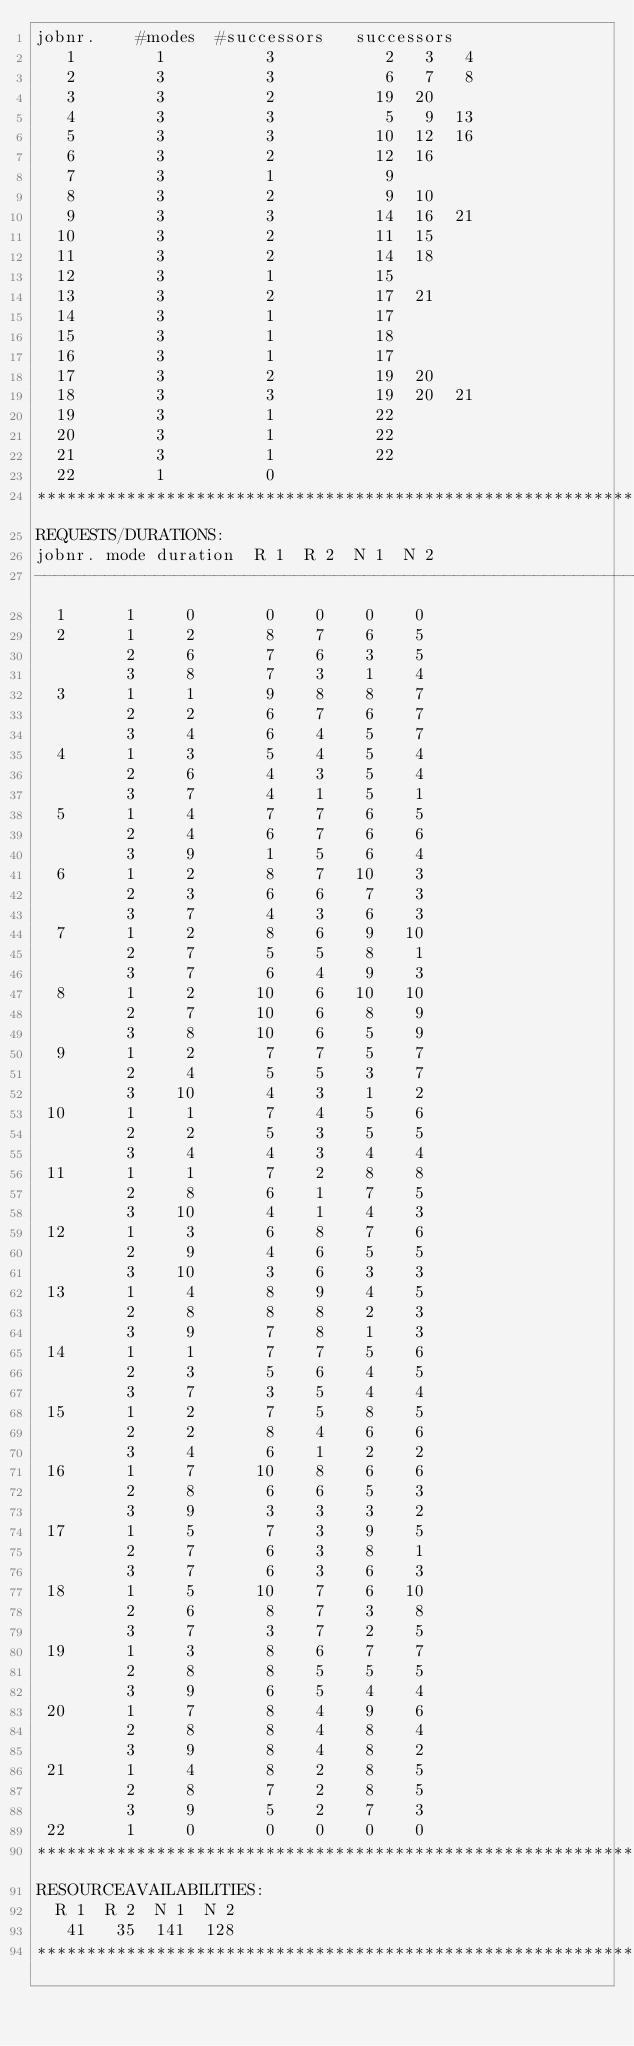<code> <loc_0><loc_0><loc_500><loc_500><_ObjectiveC_>jobnr.    #modes  #successors   successors
   1        1          3           2   3   4
   2        3          3           6   7   8
   3        3          2          19  20
   4        3          3           5   9  13
   5        3          3          10  12  16
   6        3          2          12  16
   7        3          1           9
   8        3          2           9  10
   9        3          3          14  16  21
  10        3          2          11  15
  11        3          2          14  18
  12        3          1          15
  13        3          2          17  21
  14        3          1          17
  15        3          1          18
  16        3          1          17
  17        3          2          19  20
  18        3          3          19  20  21
  19        3          1          22
  20        3          1          22
  21        3          1          22
  22        1          0        
************************************************************************
REQUESTS/DURATIONS:
jobnr. mode duration  R 1  R 2  N 1  N 2
------------------------------------------------------------------------
  1      1     0       0    0    0    0
  2      1     2       8    7    6    5
         2     6       7    6    3    5
         3     8       7    3    1    4
  3      1     1       9    8    8    7
         2     2       6    7    6    7
         3     4       6    4    5    7
  4      1     3       5    4    5    4
         2     6       4    3    5    4
         3     7       4    1    5    1
  5      1     4       7    7    6    5
         2     4       6    7    6    6
         3     9       1    5    6    4
  6      1     2       8    7   10    3
         2     3       6    6    7    3
         3     7       4    3    6    3
  7      1     2       8    6    9   10
         2     7       5    5    8    1
         3     7       6    4    9    3
  8      1     2      10    6   10   10
         2     7      10    6    8    9
         3     8      10    6    5    9
  9      1     2       7    7    5    7
         2     4       5    5    3    7
         3    10       4    3    1    2
 10      1     1       7    4    5    6
         2     2       5    3    5    5
         3     4       4    3    4    4
 11      1     1       7    2    8    8
         2     8       6    1    7    5
         3    10       4    1    4    3
 12      1     3       6    8    7    6
         2     9       4    6    5    5
         3    10       3    6    3    3
 13      1     4       8    9    4    5
         2     8       8    8    2    3
         3     9       7    8    1    3
 14      1     1       7    7    5    6
         2     3       5    6    4    5
         3     7       3    5    4    4
 15      1     2       7    5    8    5
         2     2       8    4    6    6
         3     4       6    1    2    2
 16      1     7      10    8    6    6
         2     8       6    6    5    3
         3     9       3    3    3    2
 17      1     5       7    3    9    5
         2     7       6    3    8    1
         3     7       6    3    6    3
 18      1     5      10    7    6   10
         2     6       8    7    3    8
         3     7       3    7    2    5
 19      1     3       8    6    7    7
         2     8       8    5    5    5
         3     9       6    5    4    4
 20      1     7       8    4    9    6
         2     8       8    4    8    4
         3     9       8    4    8    2
 21      1     4       8    2    8    5
         2     8       7    2    8    5
         3     9       5    2    7    3
 22      1     0       0    0    0    0
************************************************************************
RESOURCEAVAILABILITIES:
  R 1  R 2  N 1  N 2
   41   35  141  128
************************************************************************
</code> 